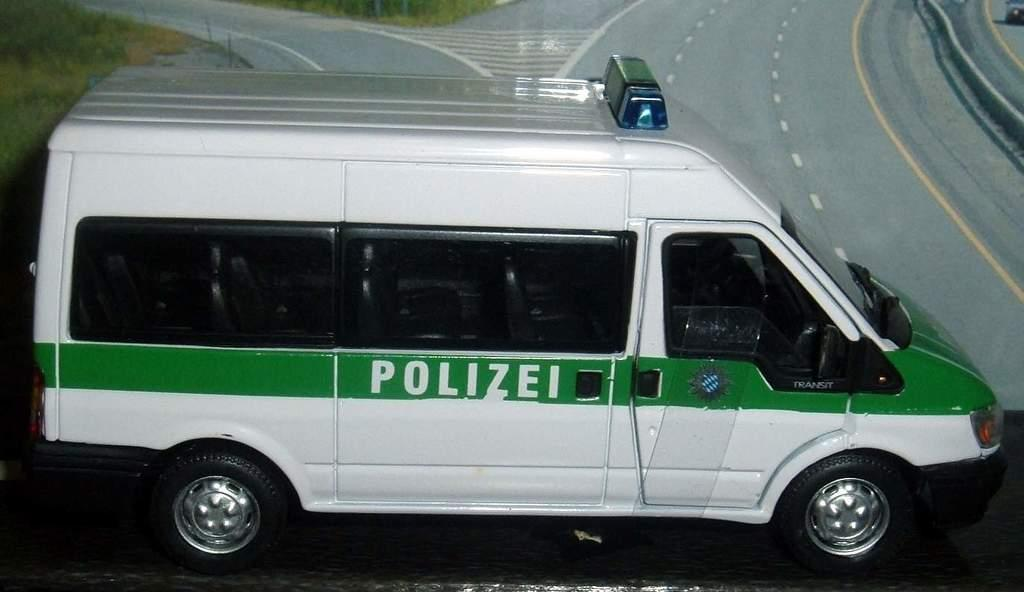<image>
Share a concise interpretation of the image provided. A white van with a green stripe on it that says Polizei. 